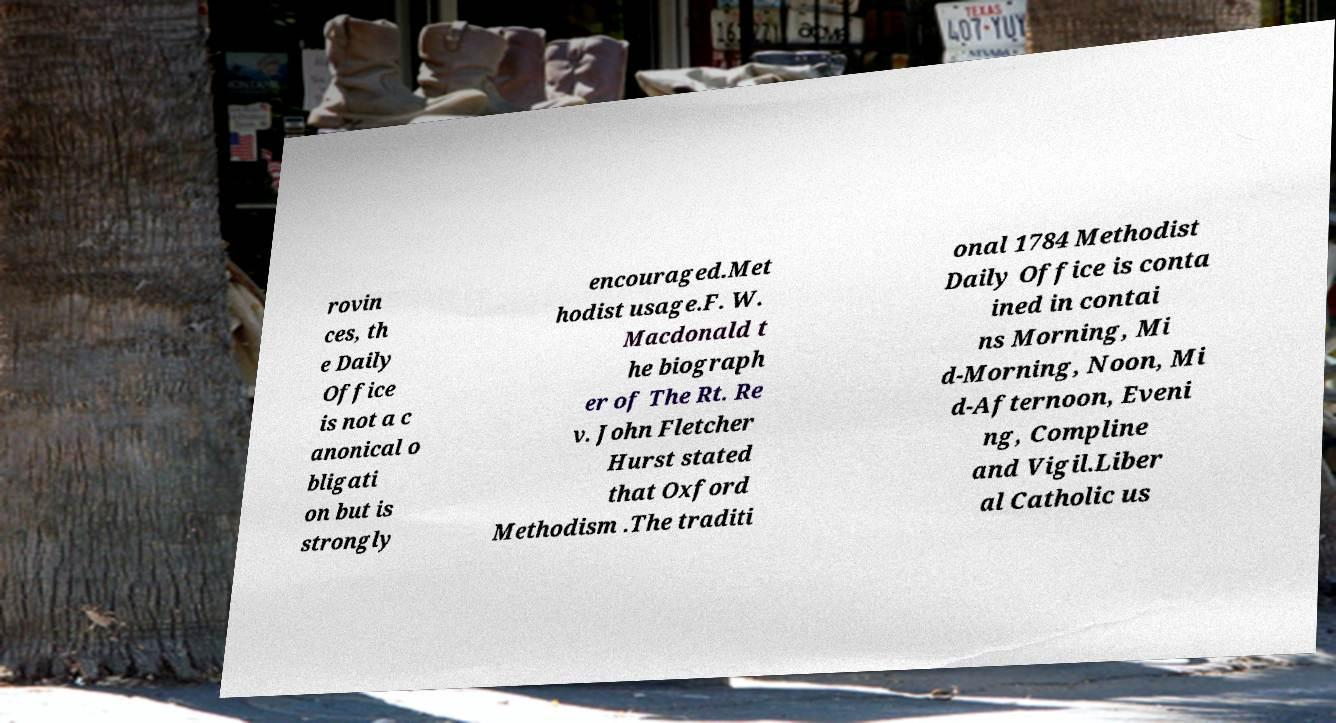There's text embedded in this image that I need extracted. Can you transcribe it verbatim? rovin ces, th e Daily Office is not a c anonical o bligati on but is strongly encouraged.Met hodist usage.F. W. Macdonald t he biograph er of The Rt. Re v. John Fletcher Hurst stated that Oxford Methodism .The traditi onal 1784 Methodist Daily Office is conta ined in contai ns Morning, Mi d-Morning, Noon, Mi d-Afternoon, Eveni ng, Compline and Vigil.Liber al Catholic us 